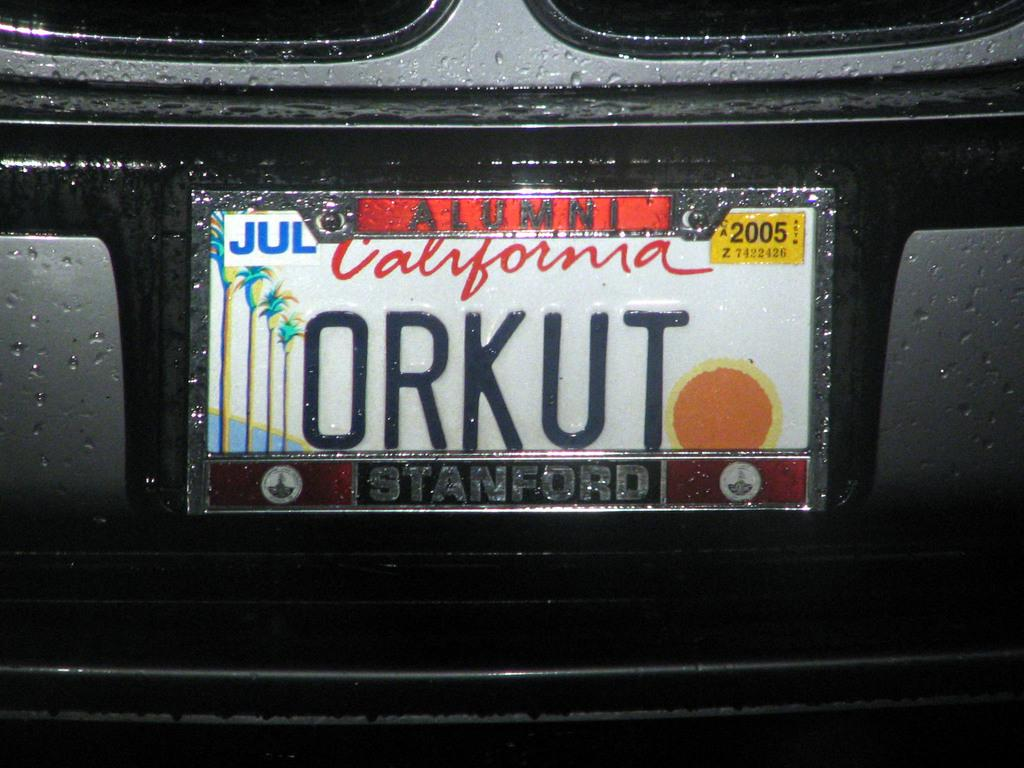<image>
Render a clear and concise summary of the photo. A car has a California license plate reading ORKUT. 